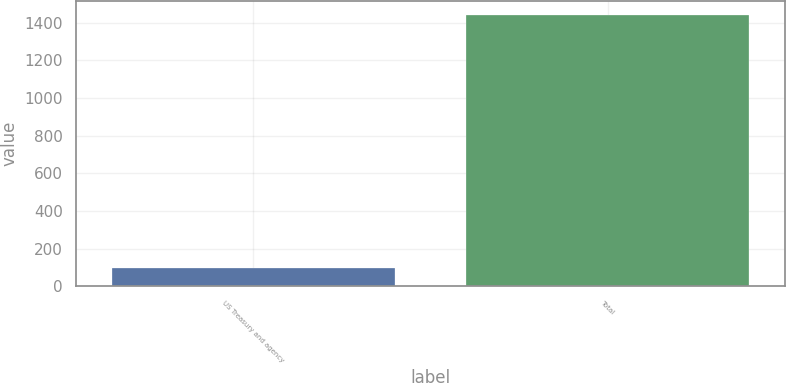Convert chart. <chart><loc_0><loc_0><loc_500><loc_500><bar_chart><fcel>US Treasury and agency<fcel>Total<nl><fcel>98<fcel>1442<nl></chart> 